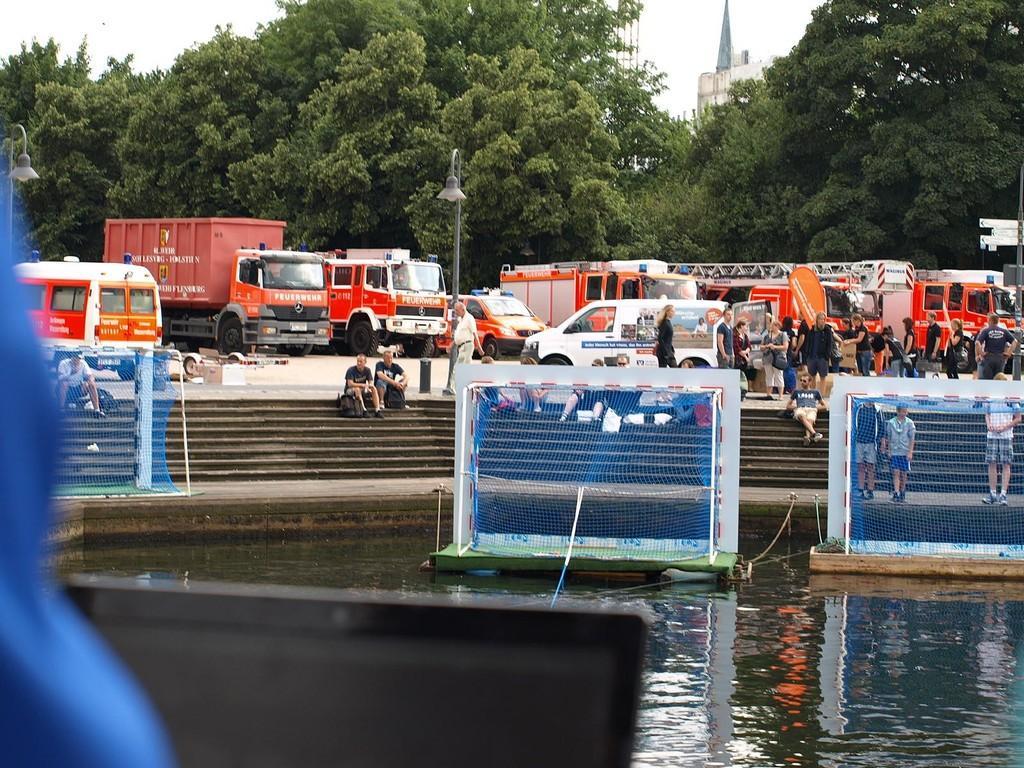Please provide a concise description of this image. In this image we can see a group of vehicles and some people standing on the ground. On the bottom of the image we can see a person with a laptop, two nets with stand placed in the water and a group of people sitting on the staircase. On the backside we can see some street lamps with poles, a group of trees, a building and the sky which looks cloudy. 